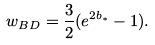Convert formula to latex. <formula><loc_0><loc_0><loc_500><loc_500>w _ { B D } = \frac { 3 } { 2 } ( e ^ { 2 b _ { \ast } } - 1 ) .</formula> 